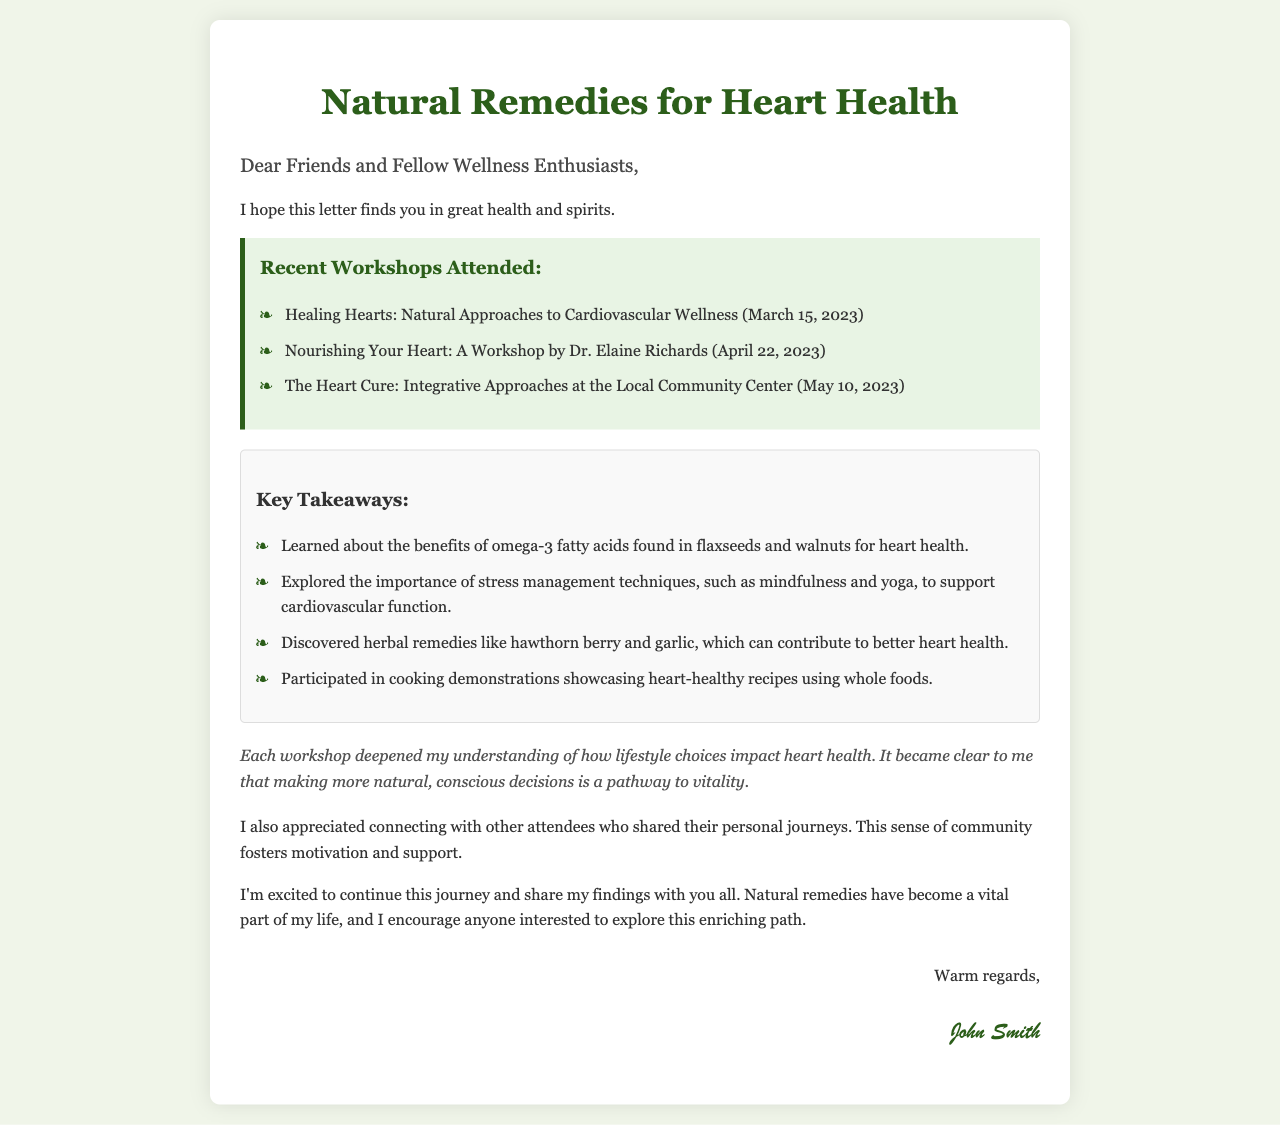What is the title of the letter? The title of the letter is stated prominently at the top of the document, summarizing the main topic of the content.
Answer: Natural Remedies for Heart Health Who conducted the workshop on April 22, 2023? The name of the workshop leader for the event on April 22 is mentioned, providing information about who facilitated the session.
Answer: Dr. Elaine Richards How many workshops are listed in the document? The document outlines a total of three workshops attended, indicated by the number of items in the list.
Answer: Three What is one key takeaway regarding stress management from the workshops? The takeaway lists specific aspects learned, including stress management techniques emphasized during the workshops.
Answer: Mindfulness and yoga What is the main reflection regarding lifestyle choices? The reflection expresses a sentiment about understanding the impact of lifestyle choices on health, encapsulated in a concise thought.
Answer: Vitality What feeling did the author express about connecting with other attendees? The author conveys an emotional aspect of the workshops, particularly the interaction with fellow participants.
Answer: Motivation and support 